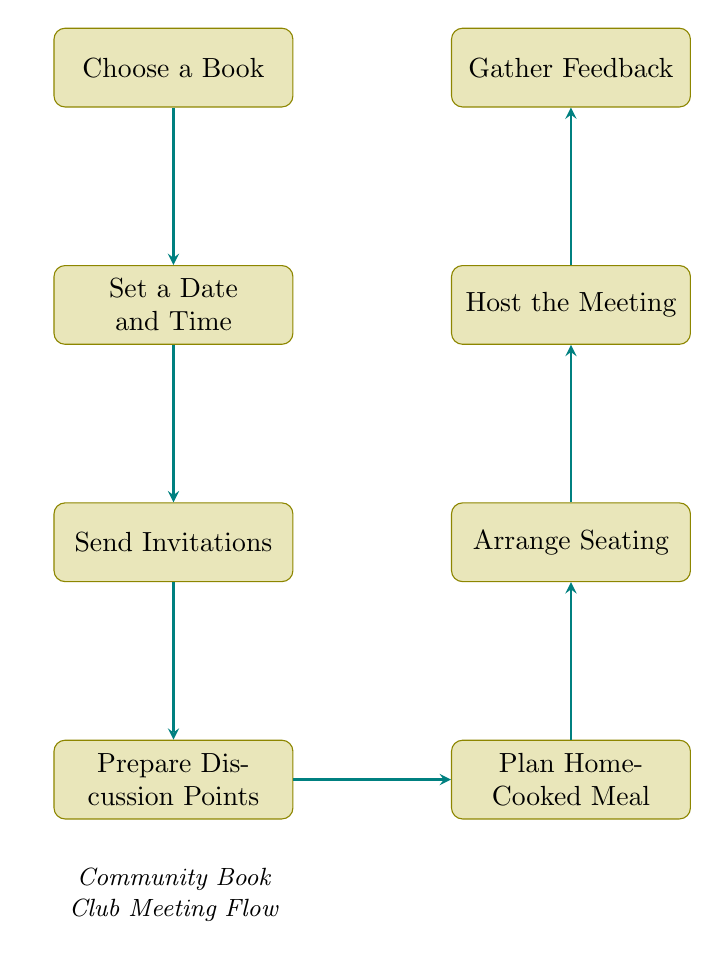What is the first step in the flowchart? The flowchart begins with the step "Choose a Book," which is the first node in the sequence.
Answer: Choose a Book How many steps are there in the flowchart? Counting each node from "Choose a Book" to "Gather Feedback," there are a total of eight distinct steps in the flowchart.
Answer: Eight What is the last action described in the flowchart? The flowchart concludes with the final step "Gather Feedback," which is the last node connected in the sequence.
Answer: Gather Feedback What follows after "Send Invitations"? The next step after "Send Invitations" is "Prepare Discussion Points," indicating the sequence in the planning process.
Answer: Prepare Discussion Points Which step is directly related to meal planning? The step "Plan Home-Cooked Meal" is directly involved with planning the meal, which occurs after preparing discussion points in the flowchart.
Answer: Plan Home-Cooked Meal How do "Arrange Seating" and "Host the Meeting" relate to each other? "Arrange Seating" directly precedes "Host the Meeting," indicating that seating must be arranged before the meeting can be hosted.
Answer: Arrange Seating before Host the Meeting What is the relationship between "Plan Home-Cooked Meal" and "Gather Feedback"? "Plan Home-Cooked Meal" comes before "Gather Feedback," as the feedback is gathered after the meal and discussion have taken place.
Answer: Meal leads to Feedback What is required before hosting the meeting? You must complete the arrangement of seating before moving on to hosting the meeting according to the flowchart's progression.
Answer: Arrange Seating 